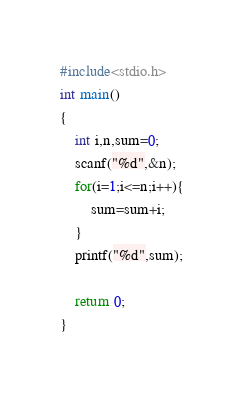<code> <loc_0><loc_0><loc_500><loc_500><_C_>#include<stdio.h>
int main()
{
    int i,n,sum=0;
    scanf("%d",&n);
    for(i=1;i<=n;i++){
        sum=sum+i;
    }
    printf("%d",sum);

    return 0;
}
</code> 